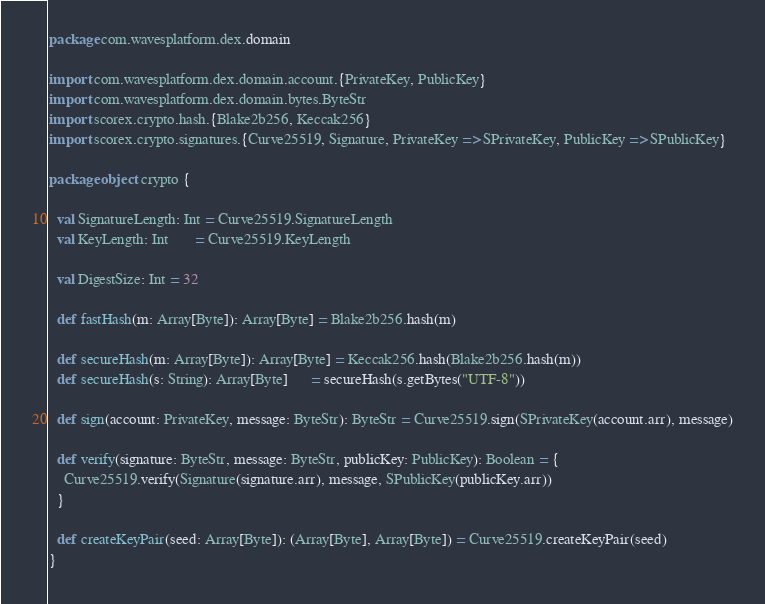Convert code to text. <code><loc_0><loc_0><loc_500><loc_500><_Scala_>package com.wavesplatform.dex.domain

import com.wavesplatform.dex.domain.account.{PrivateKey, PublicKey}
import com.wavesplatform.dex.domain.bytes.ByteStr
import scorex.crypto.hash.{Blake2b256, Keccak256}
import scorex.crypto.signatures.{Curve25519, Signature, PrivateKey => SPrivateKey, PublicKey => SPublicKey}

package object crypto {

  val SignatureLength: Int = Curve25519.SignatureLength
  val KeyLength: Int       = Curve25519.KeyLength

  val DigestSize: Int = 32

  def fastHash(m: Array[Byte]): Array[Byte] = Blake2b256.hash(m)

  def secureHash(m: Array[Byte]): Array[Byte] = Keccak256.hash(Blake2b256.hash(m))
  def secureHash(s: String): Array[Byte]      = secureHash(s.getBytes("UTF-8"))

  def sign(account: PrivateKey, message: ByteStr): ByteStr = Curve25519.sign(SPrivateKey(account.arr), message)

  def verify(signature: ByteStr, message: ByteStr, publicKey: PublicKey): Boolean = {
    Curve25519.verify(Signature(signature.arr), message, SPublicKey(publicKey.arr))
  }

  def createKeyPair(seed: Array[Byte]): (Array[Byte], Array[Byte]) = Curve25519.createKeyPair(seed)
}
</code> 